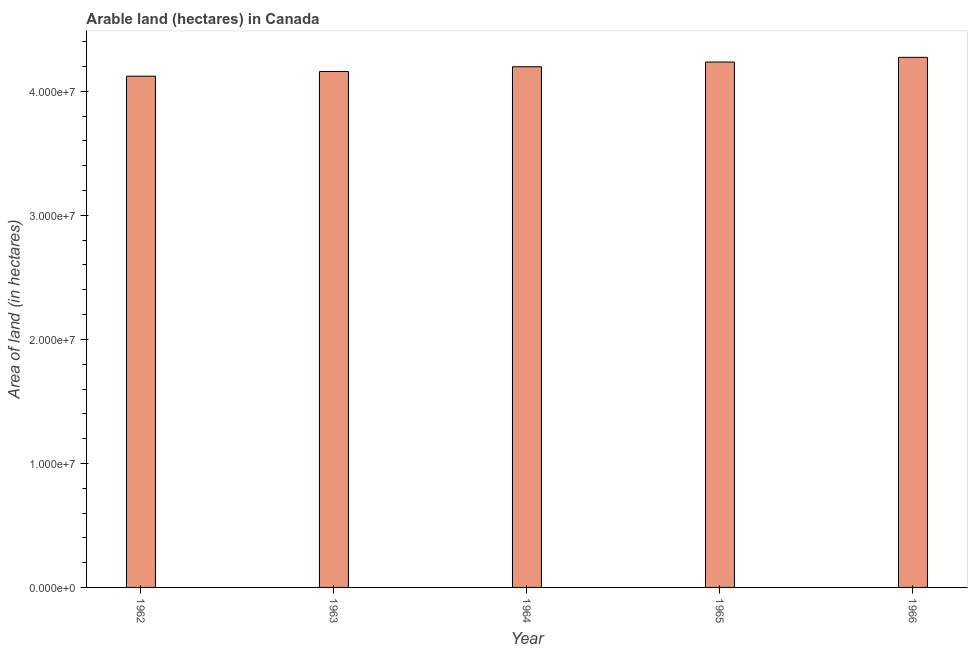What is the title of the graph?
Give a very brief answer. Arable land (hectares) in Canada. What is the label or title of the X-axis?
Keep it short and to the point. Year. What is the label or title of the Y-axis?
Your answer should be very brief. Area of land (in hectares). What is the area of land in 1963?
Offer a terse response. 4.16e+07. Across all years, what is the maximum area of land?
Your answer should be compact. 4.27e+07. Across all years, what is the minimum area of land?
Ensure brevity in your answer.  4.12e+07. In which year was the area of land maximum?
Give a very brief answer. 1966. What is the sum of the area of land?
Provide a short and direct response. 2.10e+08. What is the difference between the area of land in 1963 and 1965?
Provide a succinct answer. -7.61e+05. What is the average area of land per year?
Your answer should be compact. 4.20e+07. What is the median area of land?
Provide a succinct answer. 4.20e+07. What is the ratio of the area of land in 1965 to that in 1966?
Keep it short and to the point. 0.99. Is the area of land in 1962 less than that in 1966?
Ensure brevity in your answer.  Yes. What is the difference between the highest and the second highest area of land?
Provide a succinct answer. 3.80e+05. Is the sum of the area of land in 1962 and 1965 greater than the maximum area of land across all years?
Your response must be concise. Yes. What is the difference between the highest and the lowest area of land?
Keep it short and to the point. 1.52e+06. In how many years, is the area of land greater than the average area of land taken over all years?
Ensure brevity in your answer.  2. How many bars are there?
Your answer should be very brief. 5. How many years are there in the graph?
Ensure brevity in your answer.  5. What is the difference between two consecutive major ticks on the Y-axis?
Your answer should be very brief. 1.00e+07. Are the values on the major ticks of Y-axis written in scientific E-notation?
Provide a succinct answer. Yes. What is the Area of land (in hectares) in 1962?
Offer a terse response. 4.12e+07. What is the Area of land (in hectares) of 1963?
Offer a very short reply. 4.16e+07. What is the Area of land (in hectares) in 1964?
Give a very brief answer. 4.20e+07. What is the Area of land (in hectares) of 1965?
Ensure brevity in your answer.  4.24e+07. What is the Area of land (in hectares) in 1966?
Make the answer very short. 4.27e+07. What is the difference between the Area of land (in hectares) in 1962 and 1963?
Provide a succinct answer. -3.80e+05. What is the difference between the Area of land (in hectares) in 1962 and 1964?
Give a very brief answer. -7.60e+05. What is the difference between the Area of land (in hectares) in 1962 and 1965?
Your response must be concise. -1.14e+06. What is the difference between the Area of land (in hectares) in 1962 and 1966?
Give a very brief answer. -1.52e+06. What is the difference between the Area of land (in hectares) in 1963 and 1964?
Make the answer very short. -3.80e+05. What is the difference between the Area of land (in hectares) in 1963 and 1965?
Make the answer very short. -7.61e+05. What is the difference between the Area of land (in hectares) in 1963 and 1966?
Your answer should be compact. -1.14e+06. What is the difference between the Area of land (in hectares) in 1964 and 1965?
Give a very brief answer. -3.81e+05. What is the difference between the Area of land (in hectares) in 1964 and 1966?
Your answer should be compact. -7.61e+05. What is the difference between the Area of land (in hectares) in 1965 and 1966?
Provide a succinct answer. -3.80e+05. What is the ratio of the Area of land (in hectares) in 1962 to that in 1964?
Provide a short and direct response. 0.98. What is the ratio of the Area of land (in hectares) in 1962 to that in 1966?
Ensure brevity in your answer.  0.96. What is the ratio of the Area of land (in hectares) in 1963 to that in 1964?
Your answer should be very brief. 0.99. What is the ratio of the Area of land (in hectares) in 1963 to that in 1965?
Offer a very short reply. 0.98. What is the ratio of the Area of land (in hectares) in 1963 to that in 1966?
Keep it short and to the point. 0.97. What is the ratio of the Area of land (in hectares) in 1965 to that in 1966?
Offer a terse response. 0.99. 